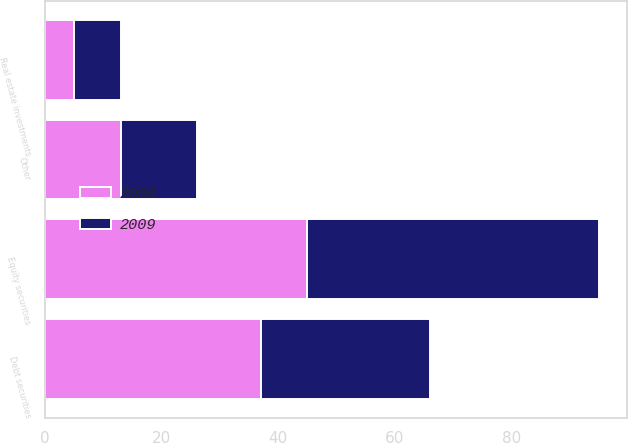<chart> <loc_0><loc_0><loc_500><loc_500><stacked_bar_chart><ecel><fcel>Equity securities<fcel>Debt securities<fcel>Real estate investments<fcel>Other<nl><fcel>2008<fcel>45<fcel>37<fcel>5<fcel>13<nl><fcel>2009<fcel>50<fcel>29<fcel>8<fcel>13<nl></chart> 